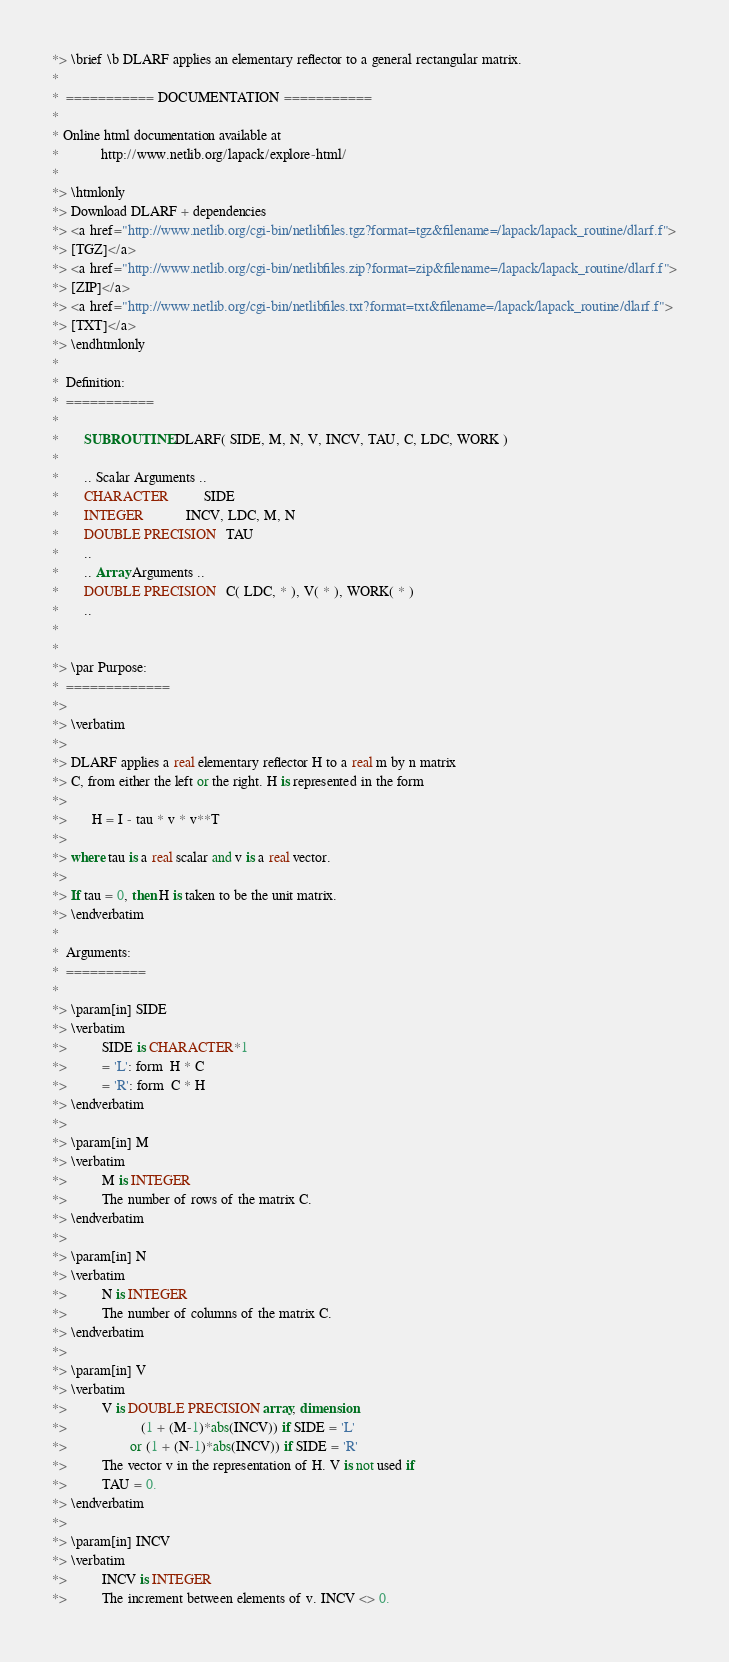Convert code to text. <code><loc_0><loc_0><loc_500><loc_500><_FORTRAN_>*> \brief \b DLARF applies an elementary reflector to a general rectangular matrix.
*
*  =========== DOCUMENTATION ===========
*
* Online html documentation available at
*            http://www.netlib.org/lapack/explore-html/
*
*> \htmlonly
*> Download DLARF + dependencies
*> <a href="http://www.netlib.org/cgi-bin/netlibfiles.tgz?format=tgz&filename=/lapack/lapack_routine/dlarf.f">
*> [TGZ]</a>
*> <a href="http://www.netlib.org/cgi-bin/netlibfiles.zip?format=zip&filename=/lapack/lapack_routine/dlarf.f">
*> [ZIP]</a>
*> <a href="http://www.netlib.org/cgi-bin/netlibfiles.txt?format=txt&filename=/lapack/lapack_routine/dlarf.f">
*> [TXT]</a>
*> \endhtmlonly
*
*  Definition:
*  ===========
*
*       SUBROUTINE DLARF( SIDE, M, N, V, INCV, TAU, C, LDC, WORK )
*
*       .. Scalar Arguments ..
*       CHARACTER          SIDE
*       INTEGER            INCV, LDC, M, N
*       DOUBLE PRECISION   TAU
*       ..
*       .. Array Arguments ..
*       DOUBLE PRECISION   C( LDC, * ), V( * ), WORK( * )
*       ..
*
*
*> \par Purpose:
*  =============
*>
*> \verbatim
*>
*> DLARF applies a real elementary reflector H to a real m by n matrix
*> C, from either the left or the right. H is represented in the form
*>
*>       H = I - tau * v * v**T
*>
*> where tau is a real scalar and v is a real vector.
*>
*> If tau = 0, then H is taken to be the unit matrix.
*> \endverbatim
*
*  Arguments:
*  ==========
*
*> \param[in] SIDE
*> \verbatim
*>          SIDE is CHARACTER*1
*>          = 'L': form  H * C
*>          = 'R': form  C * H
*> \endverbatim
*>
*> \param[in] M
*> \verbatim
*>          M is INTEGER
*>          The number of rows of the matrix C.
*> \endverbatim
*>
*> \param[in] N
*> \verbatim
*>          N is INTEGER
*>          The number of columns of the matrix C.
*> \endverbatim
*>
*> \param[in] V
*> \verbatim
*>          V is DOUBLE PRECISION array, dimension
*>                     (1 + (M-1)*abs(INCV)) if SIDE = 'L'
*>                  or (1 + (N-1)*abs(INCV)) if SIDE = 'R'
*>          The vector v in the representation of H. V is not used if
*>          TAU = 0.
*> \endverbatim
*>
*> \param[in] INCV
*> \verbatim
*>          INCV is INTEGER
*>          The increment between elements of v. INCV <> 0.</code> 